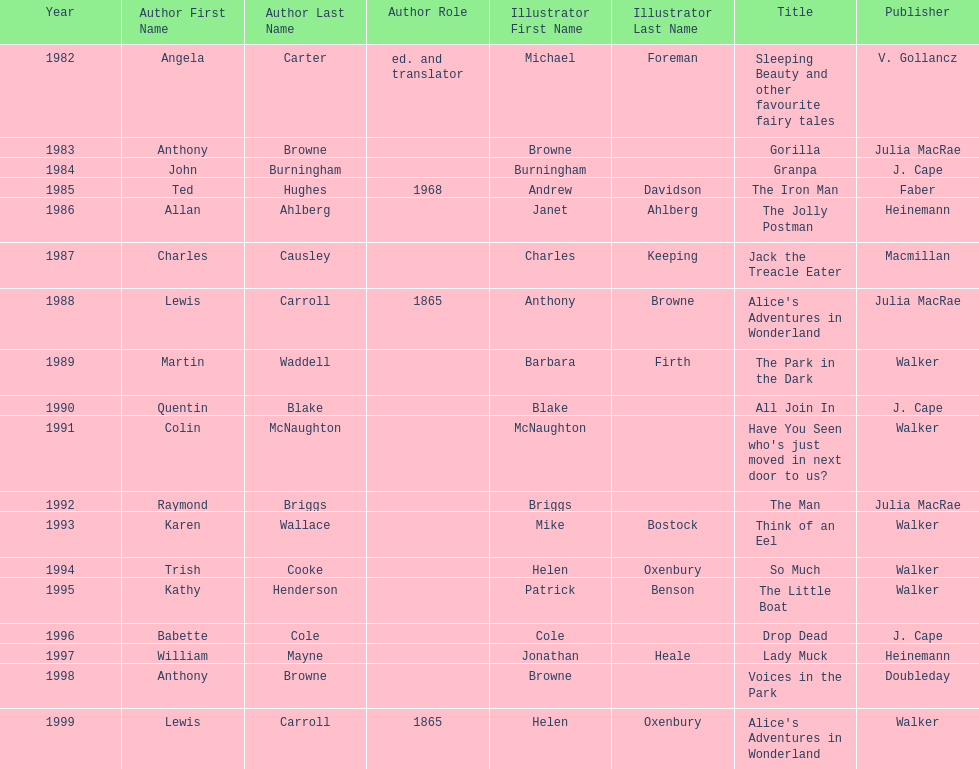How many total titles were published by walker? 5. 